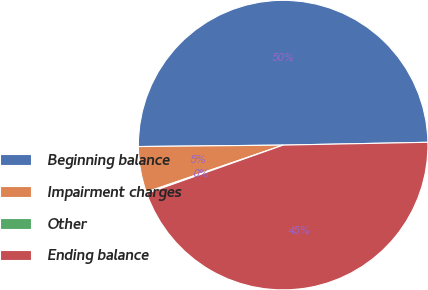Convert chart. <chart><loc_0><loc_0><loc_500><loc_500><pie_chart><fcel>Beginning balance<fcel>Impairment charges<fcel>Other<fcel>Ending balance<nl><fcel>49.85%<fcel>5.11%<fcel>0.15%<fcel>44.89%<nl></chart> 